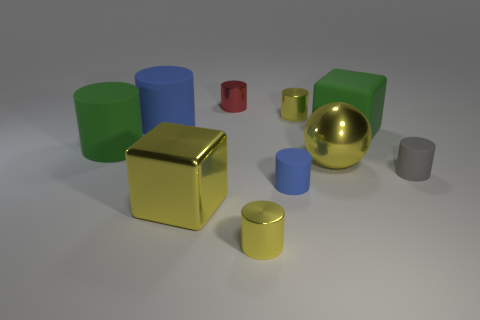Subtract all yellow metallic cylinders. How many cylinders are left? 5 Subtract all blue cylinders. How many cylinders are left? 5 Subtract 2 cubes. How many cubes are left? 0 Subtract 0 gray blocks. How many objects are left? 10 Subtract all spheres. How many objects are left? 9 Subtract all cyan balls. Subtract all green cylinders. How many balls are left? 1 Subtract all yellow cylinders. How many cyan balls are left? 0 Subtract all big blue cylinders. Subtract all big green matte things. How many objects are left? 7 Add 4 yellow shiny spheres. How many yellow shiny spheres are left? 5 Add 4 green matte cylinders. How many green matte cylinders exist? 5 